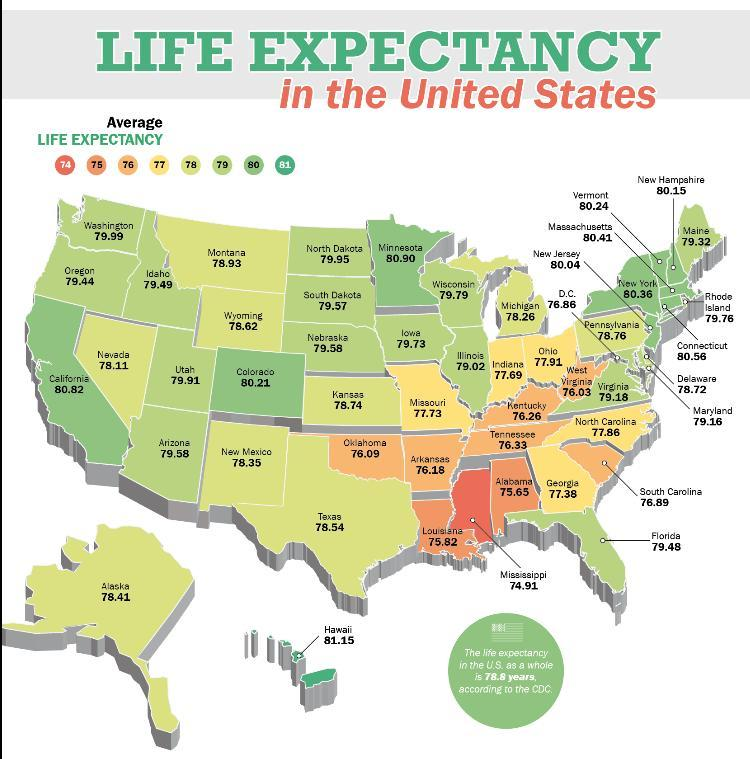What is the average life expectancy if the color of the state is yellow ?
Answer the question with a short phrase. 77 What is average life expectancy of a state if the color is red? 74 How many states have life expectancy above 81 ? 1 Which state has the average life expectancy greater than 81 ? Hawaii Which state has the life expectancy average lower than 75? Missippi 